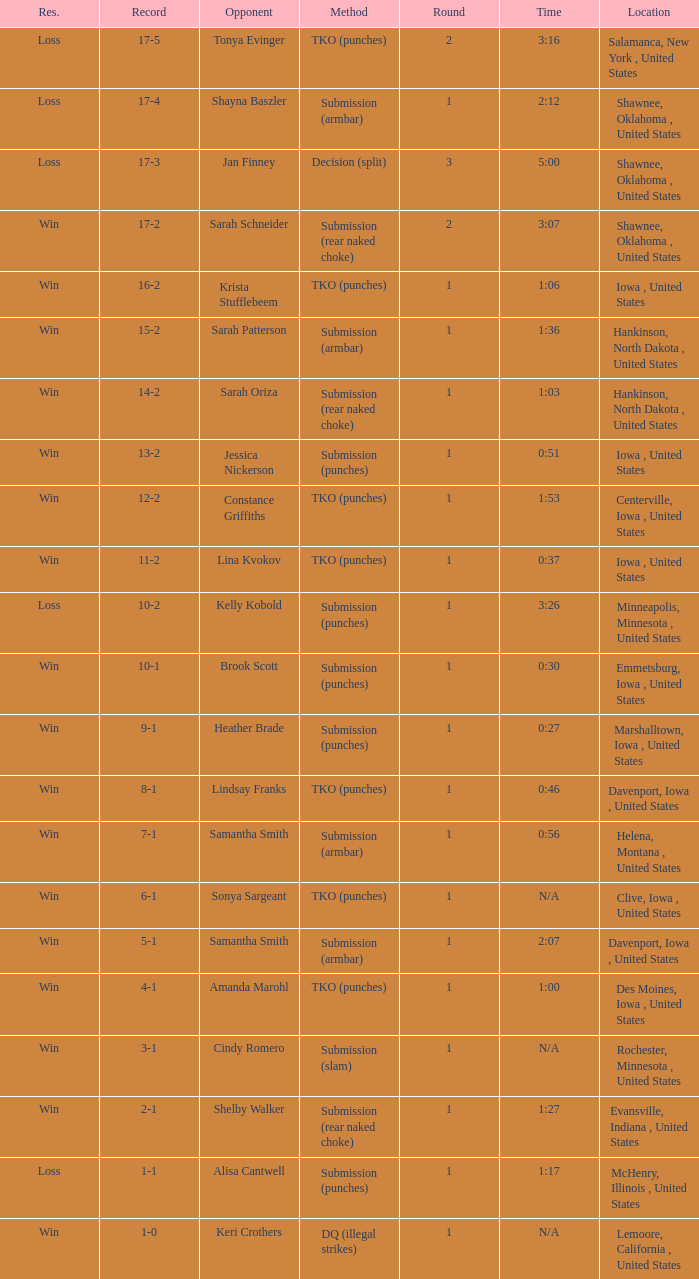Can you parse all the data within this table? {'header': ['Res.', 'Record', 'Opponent', 'Method', 'Round', 'Time', 'Location'], 'rows': [['Loss', '17-5', 'Tonya Evinger', 'TKO (punches)', '2', '3:16', 'Salamanca, New York , United States'], ['Loss', '17-4', 'Shayna Baszler', 'Submission (armbar)', '1', '2:12', 'Shawnee, Oklahoma , United States'], ['Loss', '17-3', 'Jan Finney', 'Decision (split)', '3', '5:00', 'Shawnee, Oklahoma , United States'], ['Win', '17-2', 'Sarah Schneider', 'Submission (rear naked choke)', '2', '3:07', 'Shawnee, Oklahoma , United States'], ['Win', '16-2', 'Krista Stufflebeem', 'TKO (punches)', '1', '1:06', 'Iowa , United States'], ['Win', '15-2', 'Sarah Patterson', 'Submission (armbar)', '1', '1:36', 'Hankinson, North Dakota , United States'], ['Win', '14-2', 'Sarah Oriza', 'Submission (rear naked choke)', '1', '1:03', 'Hankinson, North Dakota , United States'], ['Win', '13-2', 'Jessica Nickerson', 'Submission (punches)', '1', '0:51', 'Iowa , United States'], ['Win', '12-2', 'Constance Griffiths', 'TKO (punches)', '1', '1:53', 'Centerville, Iowa , United States'], ['Win', '11-2', 'Lina Kvokov', 'TKO (punches)', '1', '0:37', 'Iowa , United States'], ['Loss', '10-2', 'Kelly Kobold', 'Submission (punches)', '1', '3:26', 'Minneapolis, Minnesota , United States'], ['Win', '10-1', 'Brook Scott', 'Submission (punches)', '1', '0:30', 'Emmetsburg, Iowa , United States'], ['Win', '9-1', 'Heather Brade', 'Submission (punches)', '1', '0:27', 'Marshalltown, Iowa , United States'], ['Win', '8-1', 'Lindsay Franks', 'TKO (punches)', '1', '0:46', 'Davenport, Iowa , United States'], ['Win', '7-1', 'Samantha Smith', 'Submission (armbar)', '1', '0:56', 'Helena, Montana , United States'], ['Win', '6-1', 'Sonya Sargeant', 'TKO (punches)', '1', 'N/A', 'Clive, Iowa , United States'], ['Win', '5-1', 'Samantha Smith', 'Submission (armbar)', '1', '2:07', 'Davenport, Iowa , United States'], ['Win', '4-1', 'Amanda Marohl', 'TKO (punches)', '1', '1:00', 'Des Moines, Iowa , United States'], ['Win', '3-1', 'Cindy Romero', 'Submission (slam)', '1', 'N/A', 'Rochester, Minnesota , United States'], ['Win', '2-1', 'Shelby Walker', 'Submission (rear naked choke)', '1', '1:27', 'Evansville, Indiana , United States'], ['Loss', '1-1', 'Alisa Cantwell', 'Submission (punches)', '1', '1:17', 'McHenry, Illinois , United States'], ['Win', '1-0', 'Keri Crothers', 'DQ (illegal strikes)', '1', 'N/A', 'Lemoore, California , United States']]} What is the greatest number of rounds for a 3:16 combat? 2.0. 